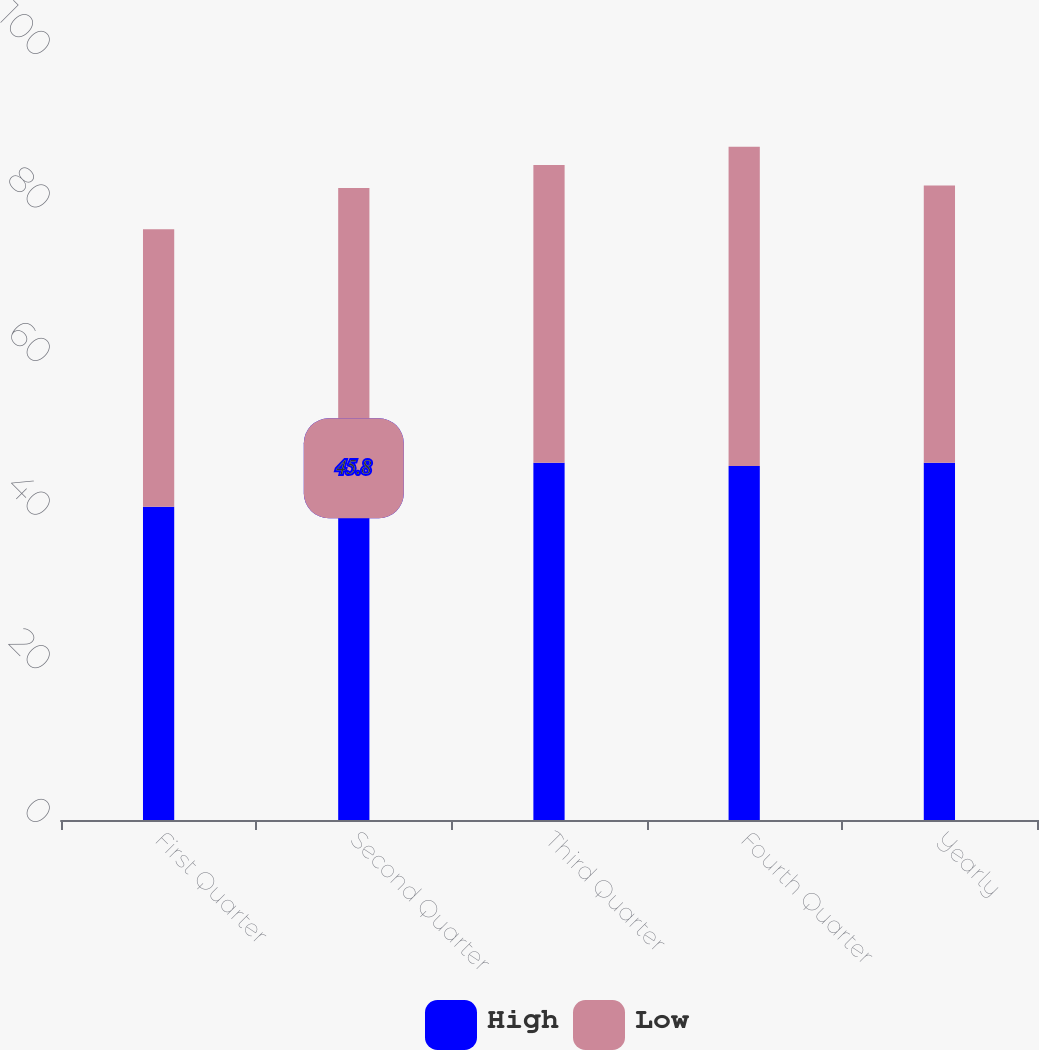<chart> <loc_0><loc_0><loc_500><loc_500><stacked_bar_chart><ecel><fcel>First Quarter<fcel>Second Quarter<fcel>Third Quarter<fcel>Fourth Quarter<fcel>Yearly<nl><fcel>High<fcel>40.8<fcel>45.8<fcel>46.51<fcel>46.1<fcel>46.51<nl><fcel>Low<fcel>36.11<fcel>36.5<fcel>38.77<fcel>41.55<fcel>36.11<nl></chart> 